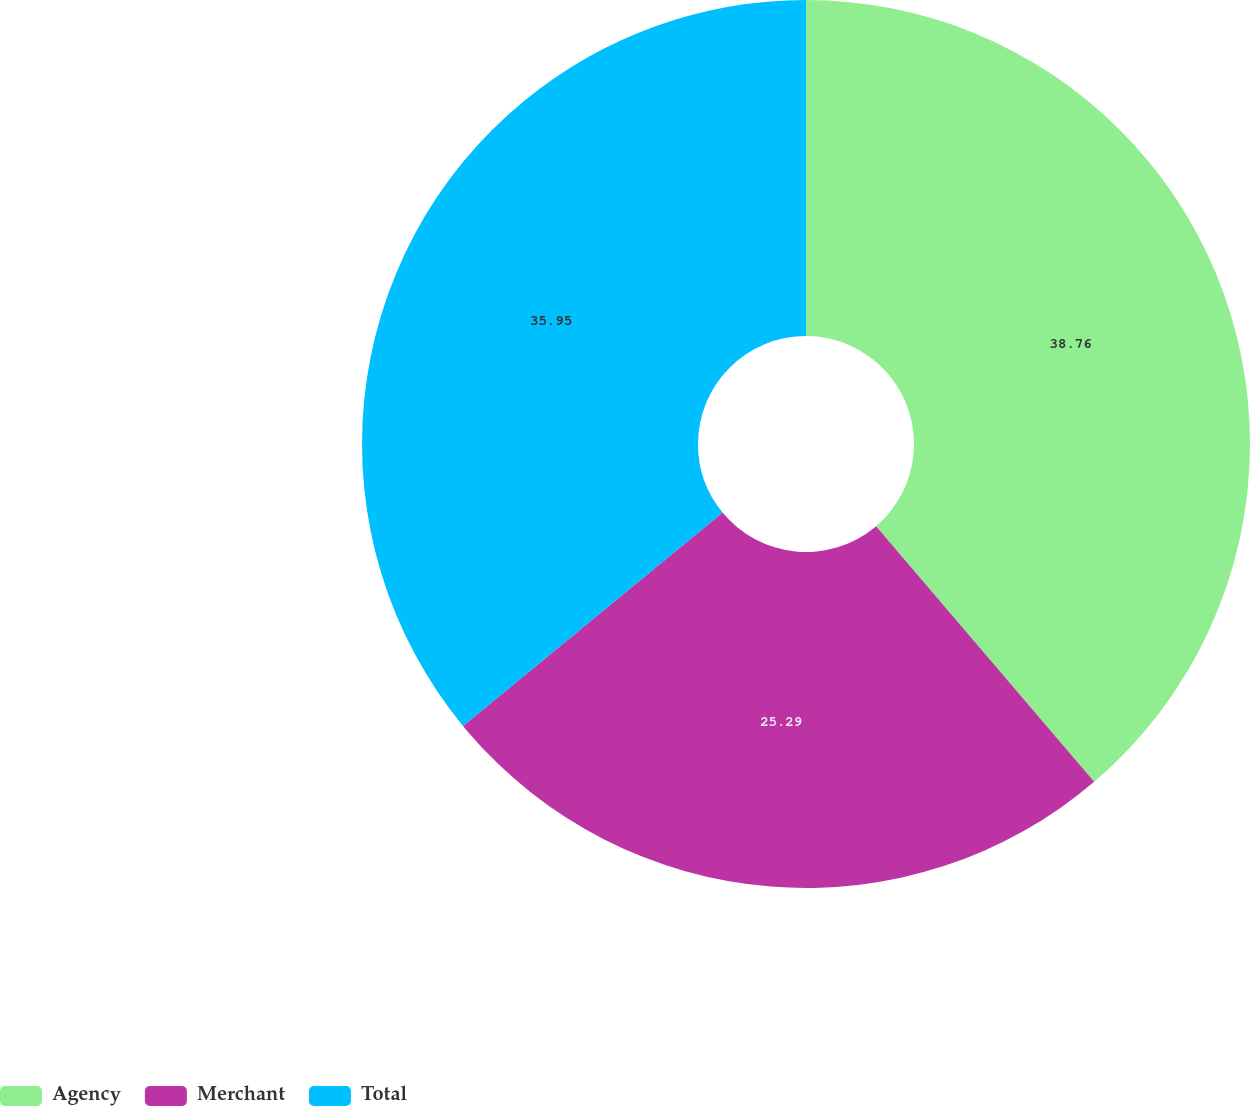Convert chart. <chart><loc_0><loc_0><loc_500><loc_500><pie_chart><fcel>Agency<fcel>Merchant<fcel>Total<nl><fcel>38.76%<fcel>25.29%<fcel>35.95%<nl></chart> 